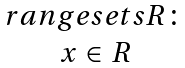Convert formula to latex. <formula><loc_0><loc_0><loc_500><loc_500>\begin{matrix} r a n g e s e t s R \colon \\ x \in R \end{matrix}</formula> 